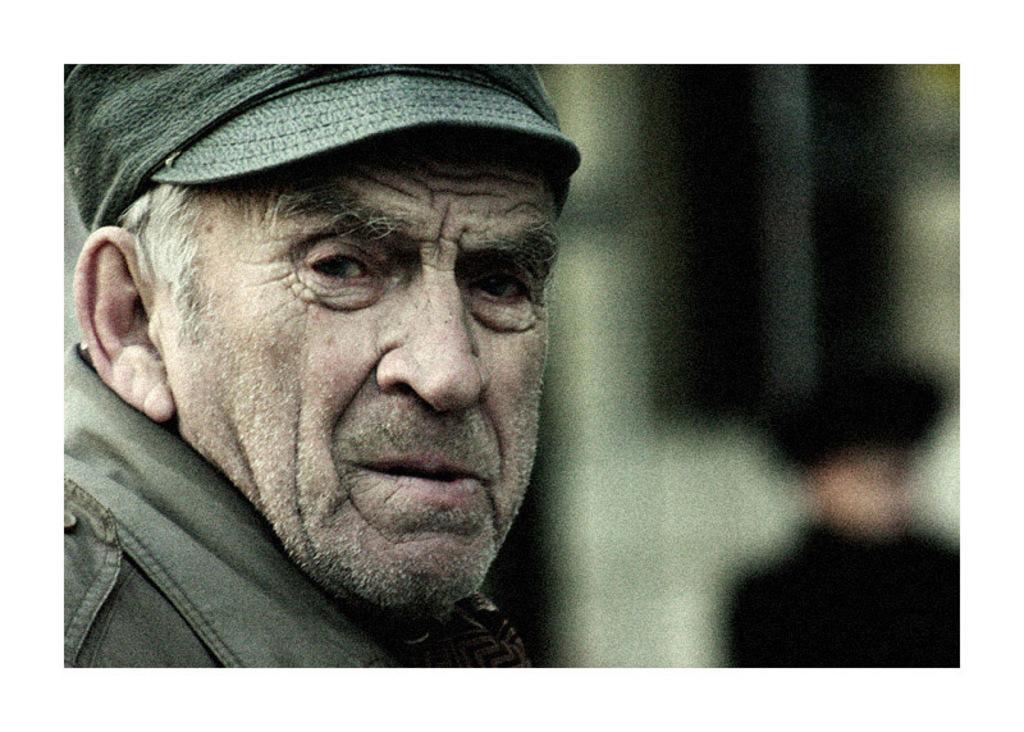How would you summarize this image in a sentence or two? In this picture we can see a person with a cap and behind the man there is a blurred background. 